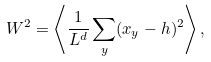Convert formula to latex. <formula><loc_0><loc_0><loc_500><loc_500>W ^ { 2 } = \left \langle \frac { 1 } { L ^ { d } } \sum _ { y } ( x _ { y } - h ) ^ { 2 } \right \rangle ,</formula> 